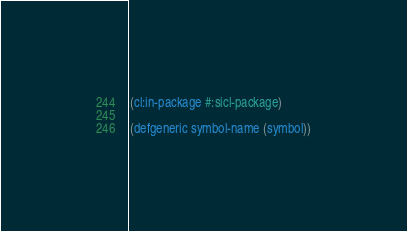<code> <loc_0><loc_0><loc_500><loc_500><_Lisp_>(cl:in-package #:sicl-package)

(defgeneric symbol-name (symbol))
</code> 